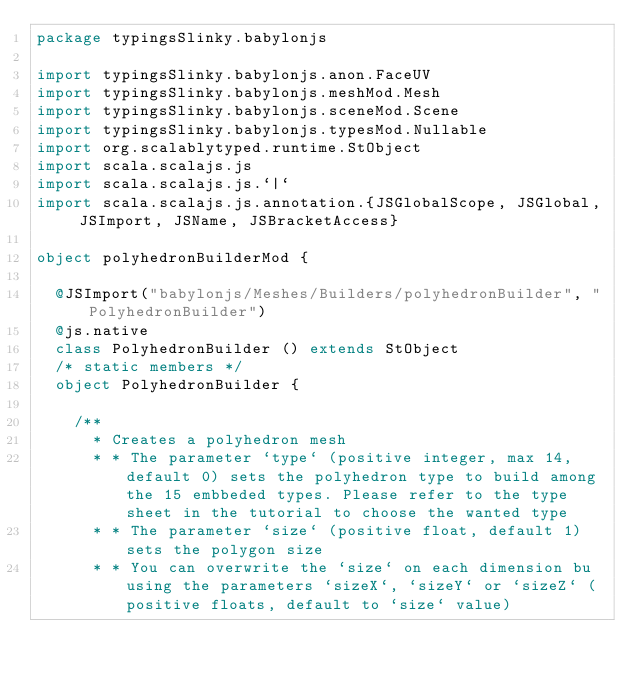Convert code to text. <code><loc_0><loc_0><loc_500><loc_500><_Scala_>package typingsSlinky.babylonjs

import typingsSlinky.babylonjs.anon.FaceUV
import typingsSlinky.babylonjs.meshMod.Mesh
import typingsSlinky.babylonjs.sceneMod.Scene
import typingsSlinky.babylonjs.typesMod.Nullable
import org.scalablytyped.runtime.StObject
import scala.scalajs.js
import scala.scalajs.js.`|`
import scala.scalajs.js.annotation.{JSGlobalScope, JSGlobal, JSImport, JSName, JSBracketAccess}

object polyhedronBuilderMod {
  
  @JSImport("babylonjs/Meshes/Builders/polyhedronBuilder", "PolyhedronBuilder")
  @js.native
  class PolyhedronBuilder () extends StObject
  /* static members */
  object PolyhedronBuilder {
    
    /**
      * Creates a polyhedron mesh
      * * The parameter `type` (positive integer, max 14, default 0) sets the polyhedron type to build among the 15 embbeded types. Please refer to the type sheet in the tutorial to choose the wanted type
      * * The parameter `size` (positive float, default 1) sets the polygon size
      * * You can overwrite the `size` on each dimension bu using the parameters `sizeX`, `sizeY` or `sizeZ` (positive floats, default to `size` value)</code> 